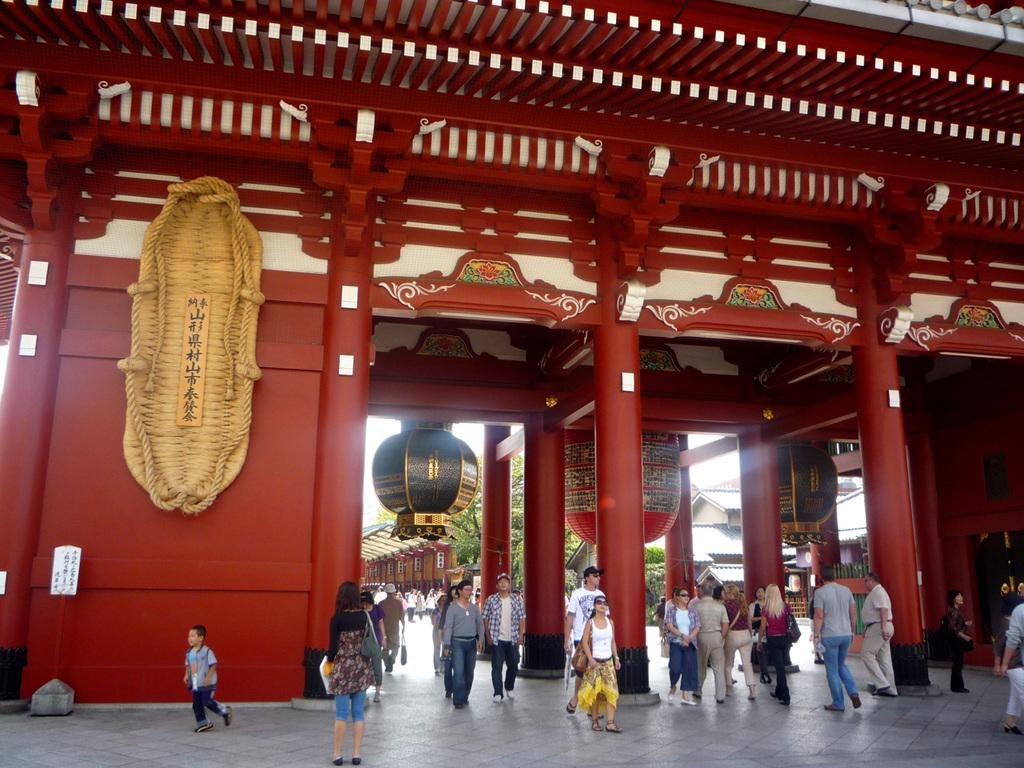Who or what can be seen in the image? There are people in the image. What architectural features are present in the image? There are pillars in the image. What type of information is displayed on the boards in the image? There is text on boards in the image. What other objects can be seen in the image? There are objects in the image. What natural elements are visible in the image? There are leaves visible in the image. What type of structures are present in the image? There are houses in the image. What type of print can be seen on the sky in the image? There is no print on the sky in the image, as the sky is a natural element and not a printed surface. How does the scale of the objects in the image compare to the size of the people? The provided facts do not give information about the scale of the objects in relation to the people, so it cannot be determined from the image. 